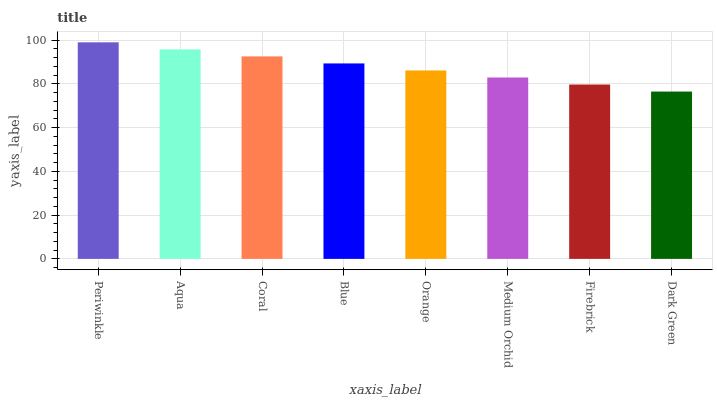Is Dark Green the minimum?
Answer yes or no. Yes. Is Periwinkle the maximum?
Answer yes or no. Yes. Is Aqua the minimum?
Answer yes or no. No. Is Aqua the maximum?
Answer yes or no. No. Is Periwinkle greater than Aqua?
Answer yes or no. Yes. Is Aqua less than Periwinkle?
Answer yes or no. Yes. Is Aqua greater than Periwinkle?
Answer yes or no. No. Is Periwinkle less than Aqua?
Answer yes or no. No. Is Blue the high median?
Answer yes or no. Yes. Is Orange the low median?
Answer yes or no. Yes. Is Aqua the high median?
Answer yes or no. No. Is Periwinkle the low median?
Answer yes or no. No. 